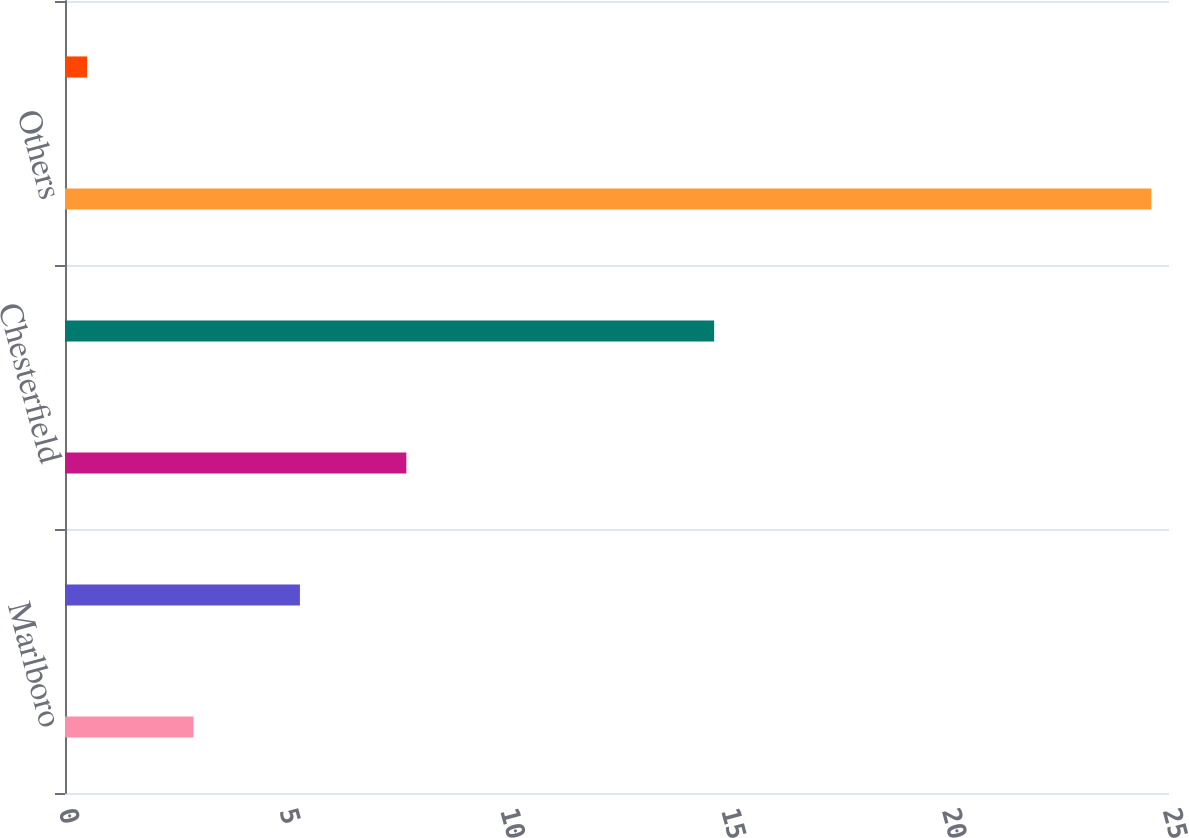Convert chart. <chart><loc_0><loc_0><loc_500><loc_500><bar_chart><fcel>Marlboro<fcel>L&M<fcel>Chesterfield<fcel>Philip Morris<fcel>Others<fcel>Total European Union<nl><fcel>2.91<fcel>5.32<fcel>7.73<fcel>14.7<fcel>24.6<fcel>0.5<nl></chart> 